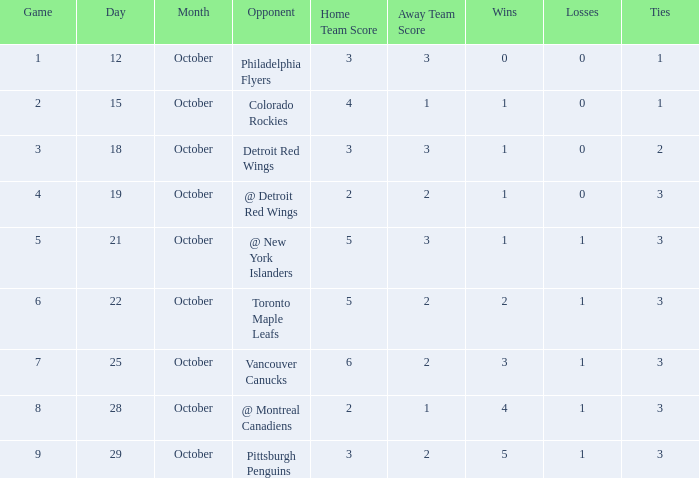Name the least game for record of 1-0-2 3.0. 